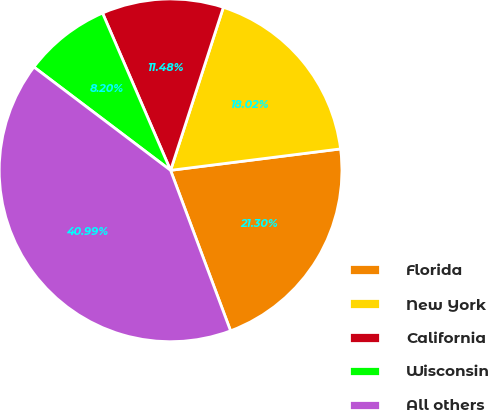Convert chart to OTSL. <chart><loc_0><loc_0><loc_500><loc_500><pie_chart><fcel>Florida<fcel>New York<fcel>California<fcel>Wisconsin<fcel>All others<nl><fcel>21.3%<fcel>18.02%<fcel>11.48%<fcel>8.2%<fcel>40.99%<nl></chart> 